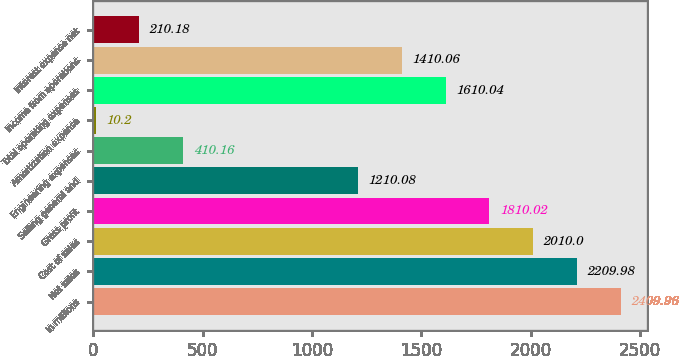Convert chart. <chart><loc_0><loc_0><loc_500><loc_500><bar_chart><fcel>In millions<fcel>Net sales<fcel>Cost of sales<fcel>Gross profit<fcel>Selling general and<fcel>Engineering expenses<fcel>Amortization expense<fcel>Total operating expenses<fcel>Income from operations<fcel>Interest expense net<nl><fcel>2409.96<fcel>2209.98<fcel>2010<fcel>1810.02<fcel>1210.08<fcel>410.16<fcel>10.2<fcel>1610.04<fcel>1410.06<fcel>210.18<nl></chart> 